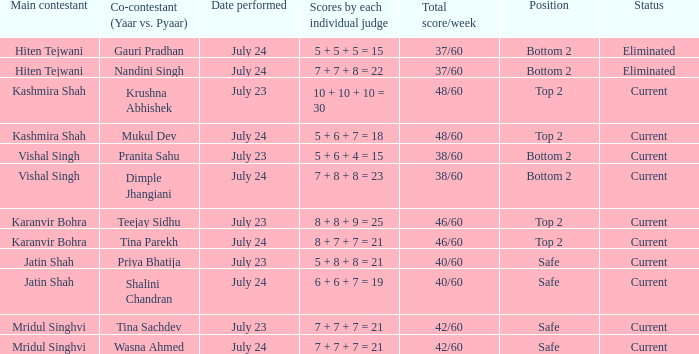Who is the fellow competitor (yaar vs. pyaar) alongside vishal singh as the primary participant? Pranita Sahu, Dimple Jhangiani. 